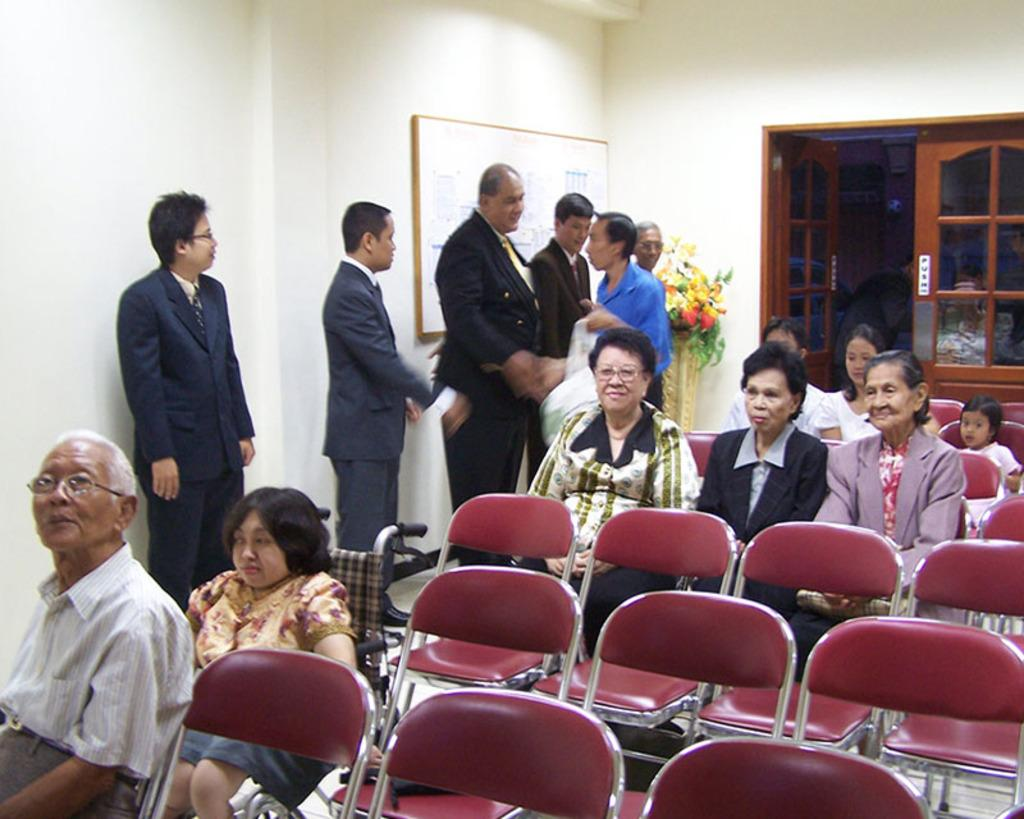What is on the wall in the image? There is a board on a wall in the image. What type of plant can be seen in the image? There is a flower plant in the image. What architectural feature is present in the image? There is a door in the image. What are the persons in the image doing? All the persons are sitting on chairs in the image. What time of day is it in the image, considering the presence of the sea? There is no sea present in the image, so it is not possible to determine the time of day based on that information. 